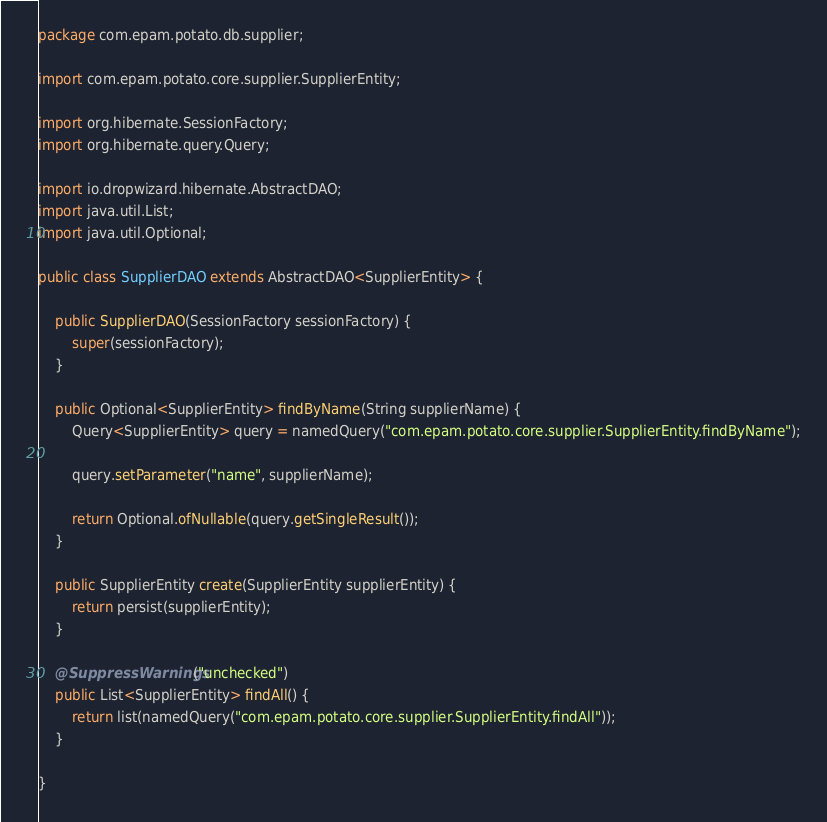<code> <loc_0><loc_0><loc_500><loc_500><_Java_>package com.epam.potato.db.supplier;

import com.epam.potato.core.supplier.SupplierEntity;

import org.hibernate.SessionFactory;
import org.hibernate.query.Query;

import io.dropwizard.hibernate.AbstractDAO;
import java.util.List;
import java.util.Optional;

public class SupplierDAO extends AbstractDAO<SupplierEntity> {

    public SupplierDAO(SessionFactory sessionFactory) {
        super(sessionFactory);
    }

    public Optional<SupplierEntity> findByName(String supplierName) {
        Query<SupplierEntity> query = namedQuery("com.epam.potato.core.supplier.SupplierEntity.findByName");

        query.setParameter("name", supplierName);

        return Optional.ofNullable(query.getSingleResult());
    }

    public SupplierEntity create(SupplierEntity supplierEntity) {
        return persist(supplierEntity);
    }

    @SuppressWarnings("unchecked")
    public List<SupplierEntity> findAll() {
        return list(namedQuery("com.epam.potato.core.supplier.SupplierEntity.findAll"));
    }

}
</code> 